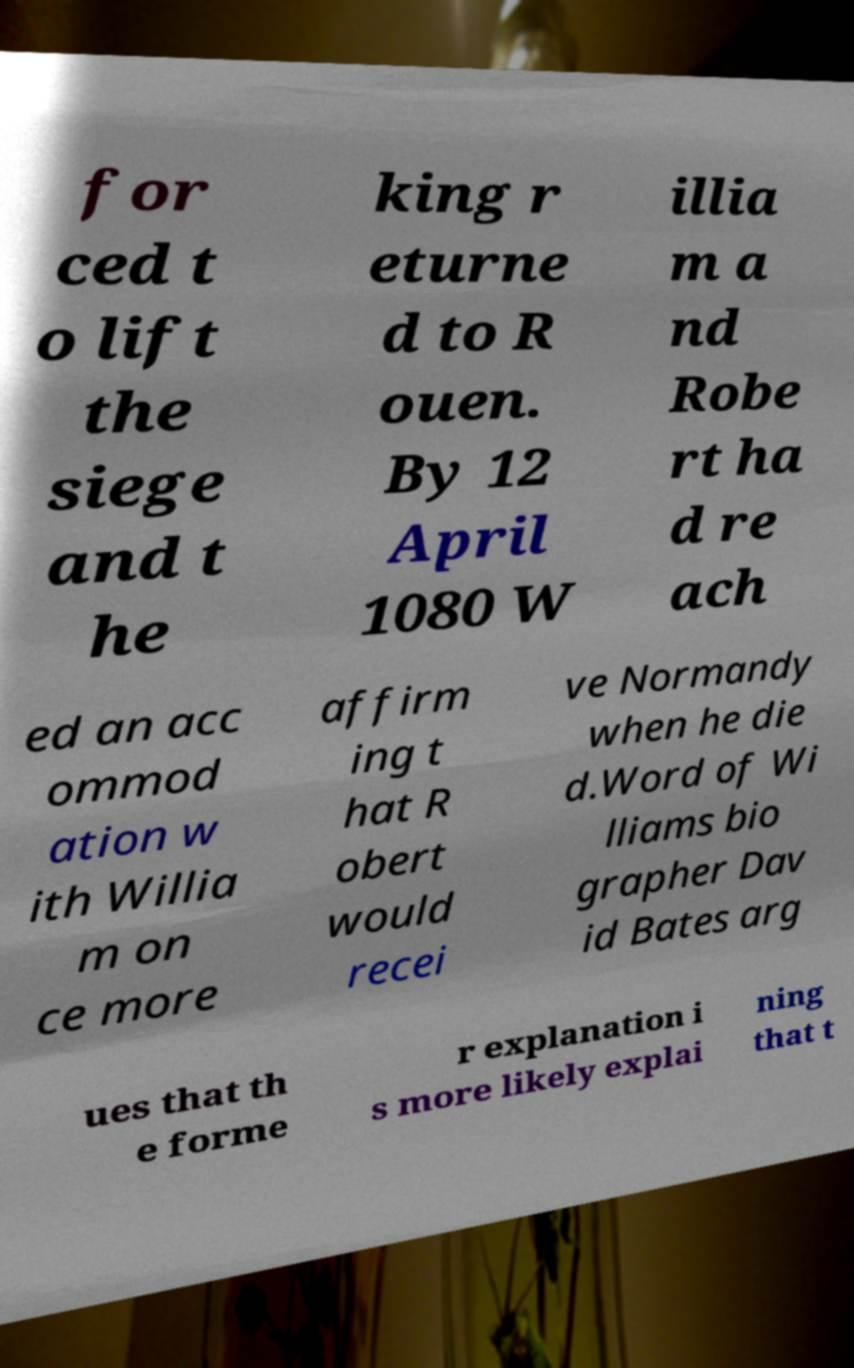Can you accurately transcribe the text from the provided image for me? for ced t o lift the siege and t he king r eturne d to R ouen. By 12 April 1080 W illia m a nd Robe rt ha d re ach ed an acc ommod ation w ith Willia m on ce more affirm ing t hat R obert would recei ve Normandy when he die d.Word of Wi lliams bio grapher Dav id Bates arg ues that th e forme r explanation i s more likely explai ning that t 